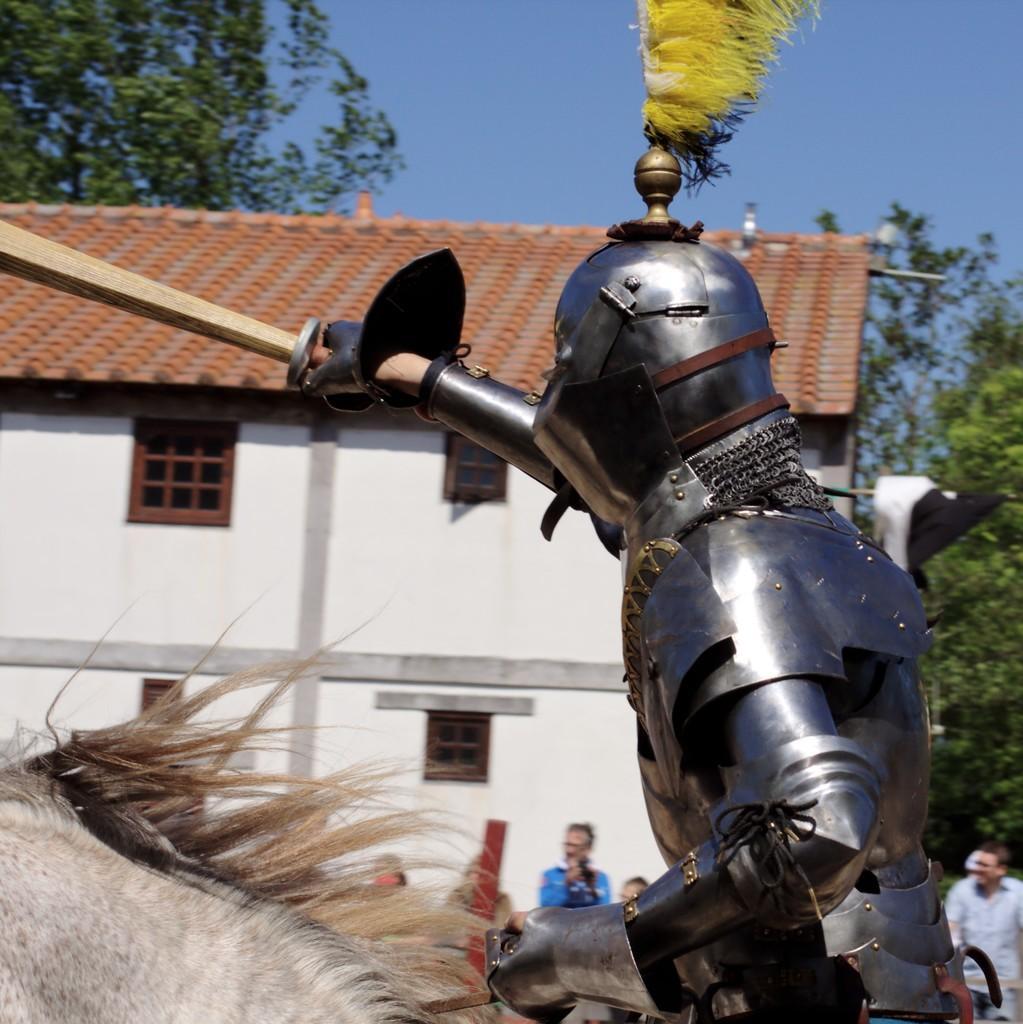Describe this image in one or two sentences. In this image I can see a building,windows,trees,few people and one person is wearing a different costume and holding something. The sky is in blue color. 